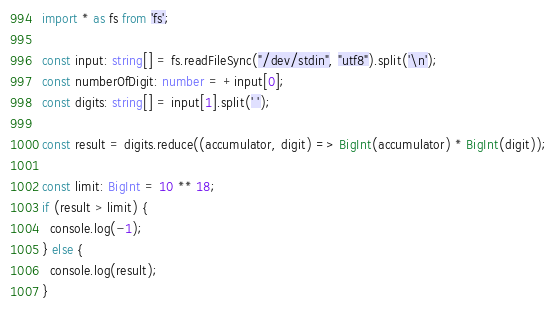Convert code to text. <code><loc_0><loc_0><loc_500><loc_500><_TypeScript_>import * as fs from 'fs';

const input: string[] = fs.readFileSync("/dev/stdin", "utf8").split('\n');
const numberOfDigit: number = +input[0];
const digits: string[] = input[1].split(' ');

const result = digits.reduce((accumulator, digit) => BigInt(accumulator) * BigInt(digit));

const limit: BigInt = 10 ** 18;
if (result > limit) {
  console.log(-1);
} else {
  console.log(result);
}
</code> 